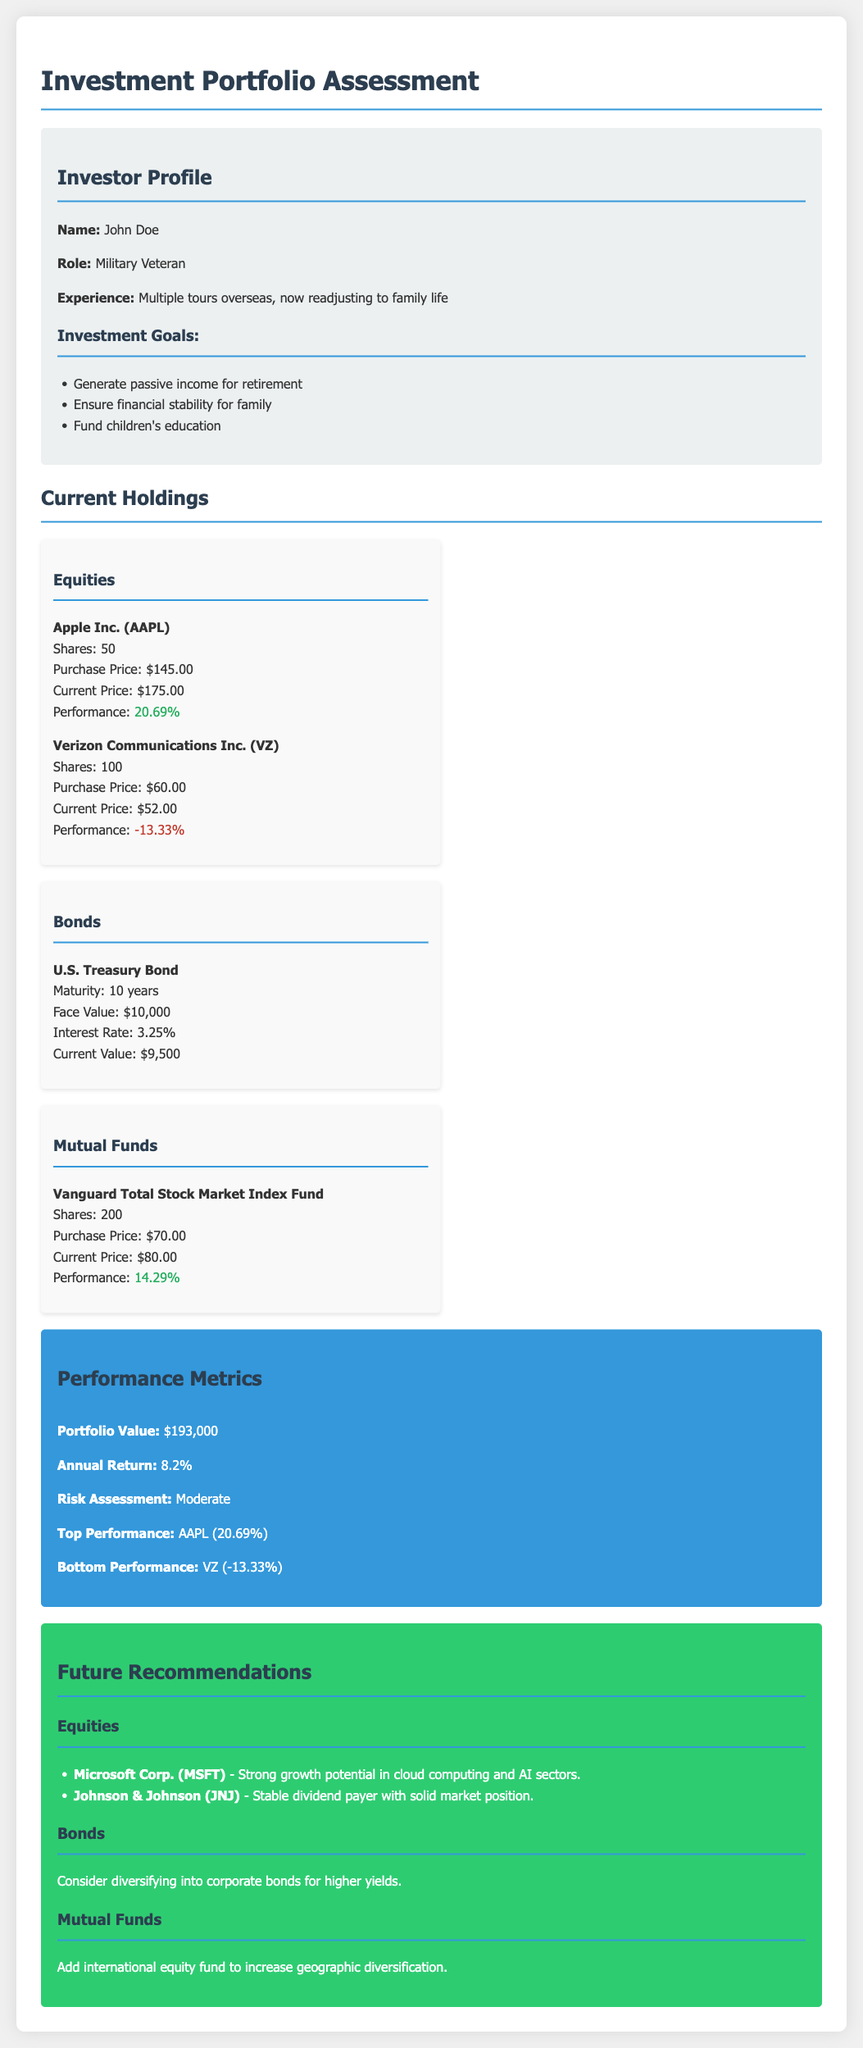What is the investor's name? The investor's name is provided in the profile section of the document.
Answer: John Doe What is the annual return of the portfolio? The annual return is stated in the performance metrics section of the document.
Answer: 8.2% How many shares of Apple Inc. does the investor own? The number of shares is listed under current holdings in the equities section.
Answer: 50 What is the performance percentage of Verizon Communications Inc.? The performance percentage can be found under the equities section for Verizon.
Answer: -13.33% What is the face value of the U.S. Treasury Bond? The face value is included in the bonds section of the current holdings.
Answer: $10,000 Which mutual fund is mentioned in the holdings? The mutual fund is indicated in the current holdings section under mutual funds.
Answer: Vanguard Total Stock Market Index Fund What type of investment does the document recommend adding for diversification? The recommendation for diversification is mentioned in the mutual funds section of the recommendations.
Answer: International equity fund What is the top-performing equity in the portfolio? The top-performing equity is highlighted in the performance metrics section.
Answer: AAPL (20.69%) What is the risk assessment of the portfolio? The risk assessment is provided in the performance metrics section of the document.
Answer: Moderate 